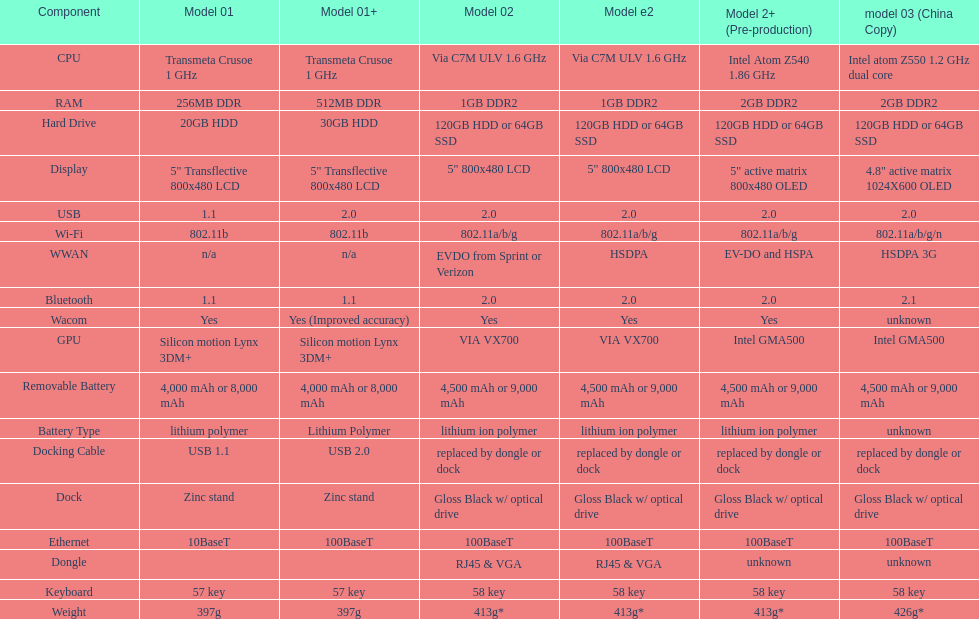What comes after the 30gb model in terms of higher capacity hard drives? 64GB SSD. 